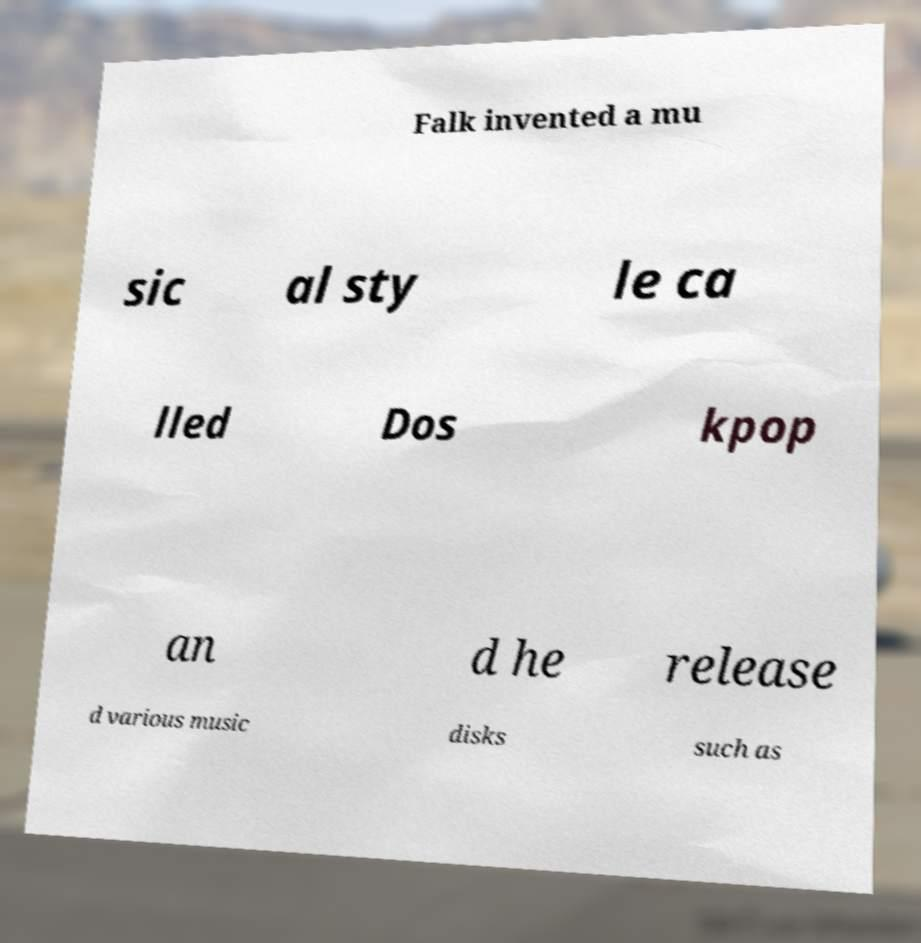What messages or text are displayed in this image? I need them in a readable, typed format. Falk invented a mu sic al sty le ca lled Dos kpop an d he release d various music disks such as 